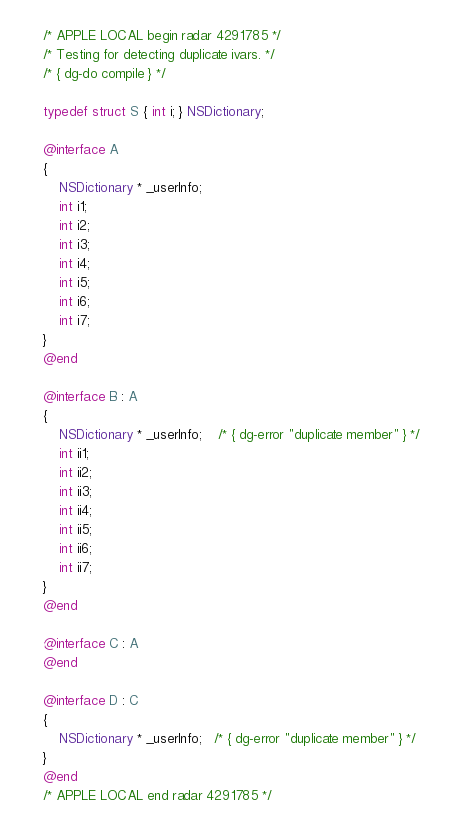<code> <loc_0><loc_0><loc_500><loc_500><_ObjectiveC_>/* APPLE LOCAL begin radar 4291785 */
/* Testing for detecting duplicate ivars. */
/* { dg-do compile } */

typedef struct S { int i; } NSDictionary;

@interface A 
{
    NSDictionary * _userInfo;
    int i1;
    int i2;
    int i3;
    int i4;
    int i5;
    int i6;
    int i7;
}
@end

@interface B : A
{
    NSDictionary * _userInfo;	/* { dg-error "duplicate member" } */
    int ii1;
    int ii2;
    int ii3;
    int ii4;
    int ii5;
    int ii6;
    int ii7;
}	
@end

@interface C : A
@end

@interface D : C
{
    NSDictionary * _userInfo;   /* { dg-error "duplicate member" } */
}
@end
/* APPLE LOCAL end radar 4291785 */
</code> 